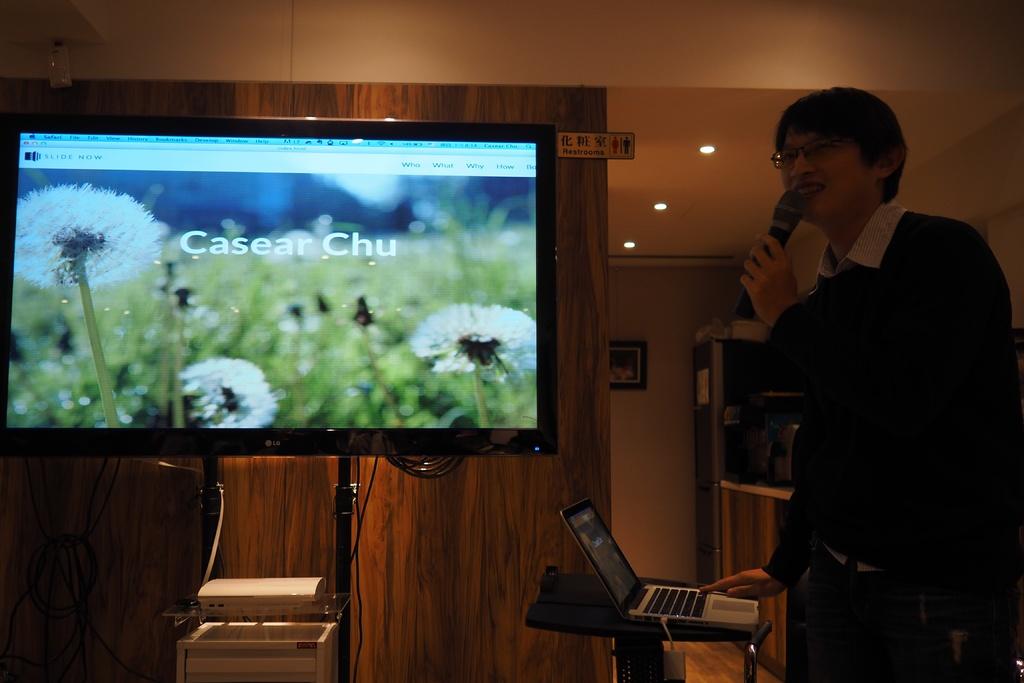Who is speaking?
Keep it short and to the point. Casear chu. What is the speakers name?
Your answer should be very brief. Casear chu. 